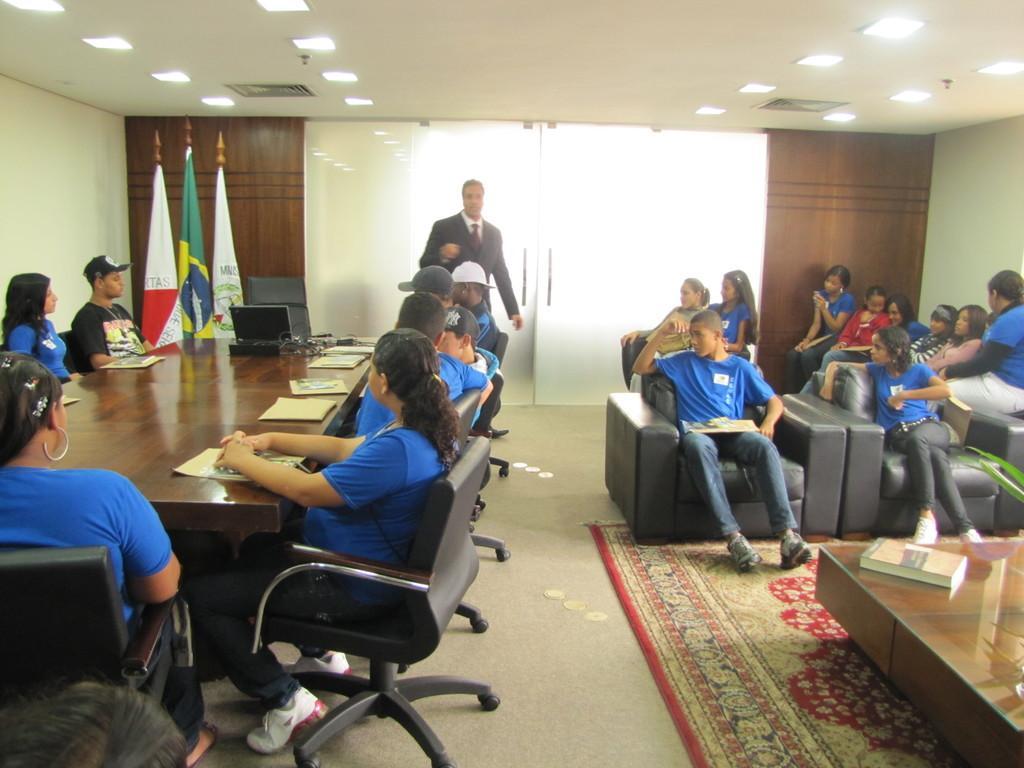In one or two sentences, can you explain what this image depicts? This is the picture inside the room. There are group of people in the image. There is a book, papers, laptop on the table. At the left side of the image there are flags, at the right side of the image there is a plant, at the bottom there is a mat, at the top there are lights, at the back side there is a door. 